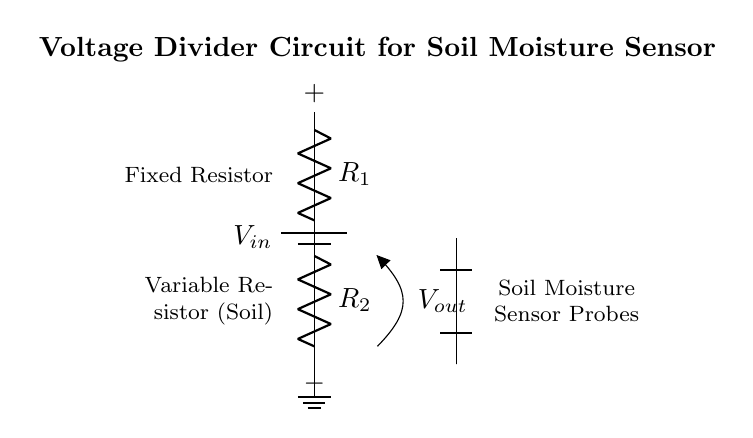What type of circuit is depicted? The circuit is a voltage divider circuit, characterized by two resistors arranged to divide input voltage based on their resistance values.
Answer: Voltage divider What does the variable resistor represent? The variable resistor in the circuit represents the resistance of the soil, which changes with moisture content. This affects the output voltage in relation to soil moisture levels.
Answer: Soil moisture What is the function of the fixed resistor? The fixed resistor serves to limit the current and create a voltage drop, allowing for the measurement of output voltage, which indicates the moisture level in the soil.
Answer: Current limitation What is the output voltage source in the circuit? The output voltage is derived from the voltage drop across the variable resistor, which varies as soil moisture changes. This voltage is used to provide an indication of soil moisture.
Answer: Output voltage How many resistors are present in the circuit? There are two resistors in the circuit: one fixed and one variable, which together form the voltage divider necessary for sensing soil moisture.
Answer: Two resistors What does the '+' and '−' symbol indicate? The '+' symbol indicates the positive terminal of the voltage source, while the '−' symbol represents the negative terminal, indicating the direction of current flow in the circuit.
Answer: Positive and negative terminals What is the significance of the soil moisture sensor probes? The soil moisture sensor probes measure the moisture level by providing a means to interface with the variable resistor in the circuit, allowing the system to sense changes in resistance due to soil moisture.
Answer: Measurement interface 